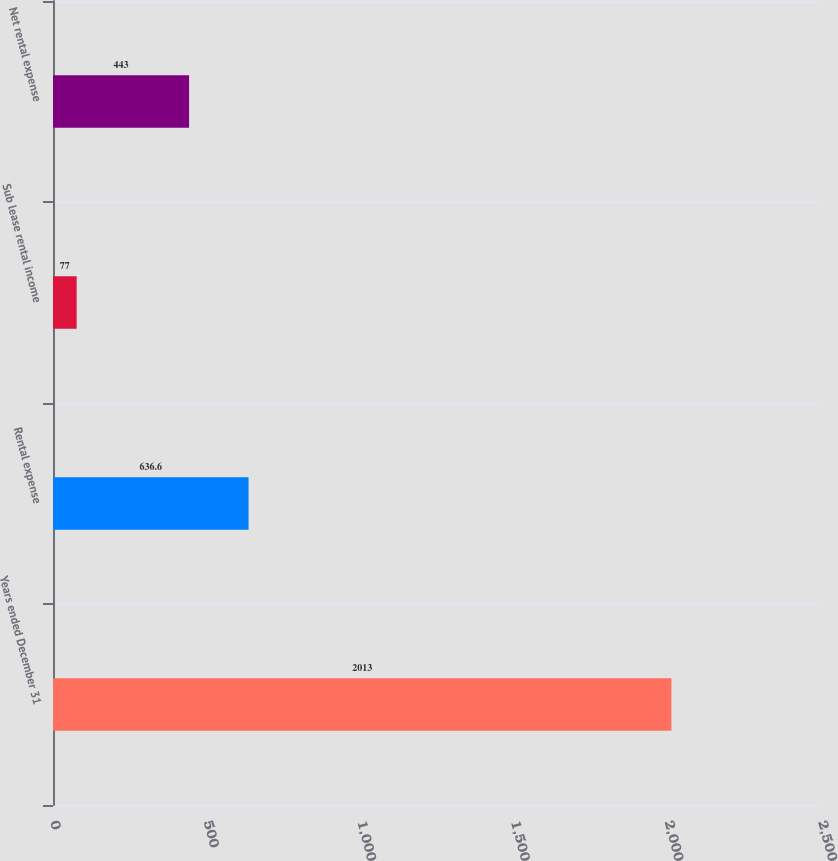<chart> <loc_0><loc_0><loc_500><loc_500><bar_chart><fcel>Years ended December 31<fcel>Rental expense<fcel>Sub lease rental income<fcel>Net rental expense<nl><fcel>2013<fcel>636.6<fcel>77<fcel>443<nl></chart> 